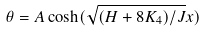<formula> <loc_0><loc_0><loc_500><loc_500>\theta = A \cosh ( \sqrt { ( H + 8 K _ { 4 } ) / J } x )</formula> 